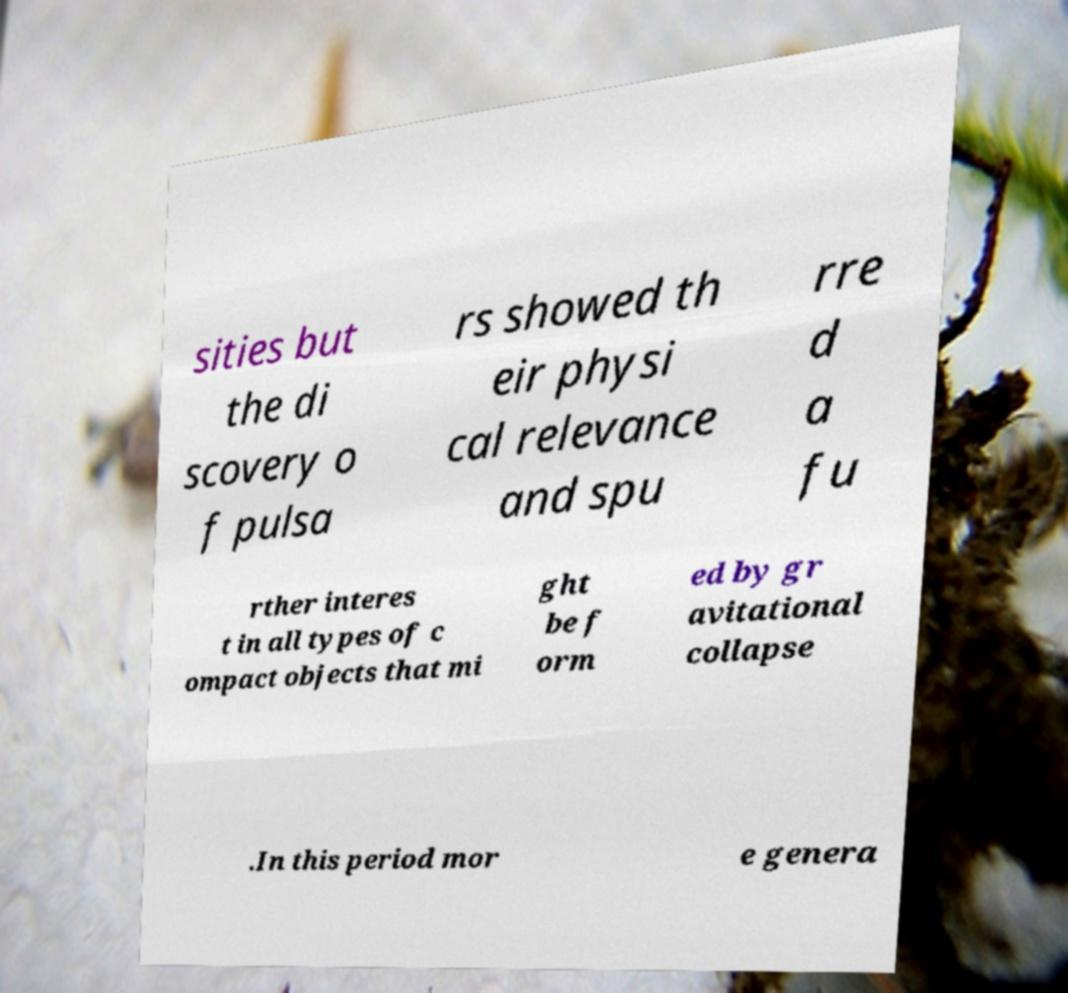There's text embedded in this image that I need extracted. Can you transcribe it verbatim? sities but the di scovery o f pulsa rs showed th eir physi cal relevance and spu rre d a fu rther interes t in all types of c ompact objects that mi ght be f orm ed by gr avitational collapse .In this period mor e genera 